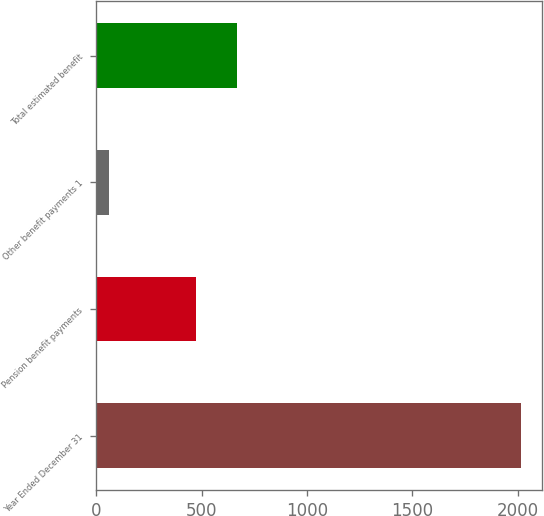<chart> <loc_0><loc_0><loc_500><loc_500><bar_chart><fcel>Year Ended December 31<fcel>Pension benefit payments<fcel>Other benefit payments 1<fcel>Total estimated benefit<nl><fcel>2014<fcel>473<fcel>61<fcel>668.3<nl></chart> 